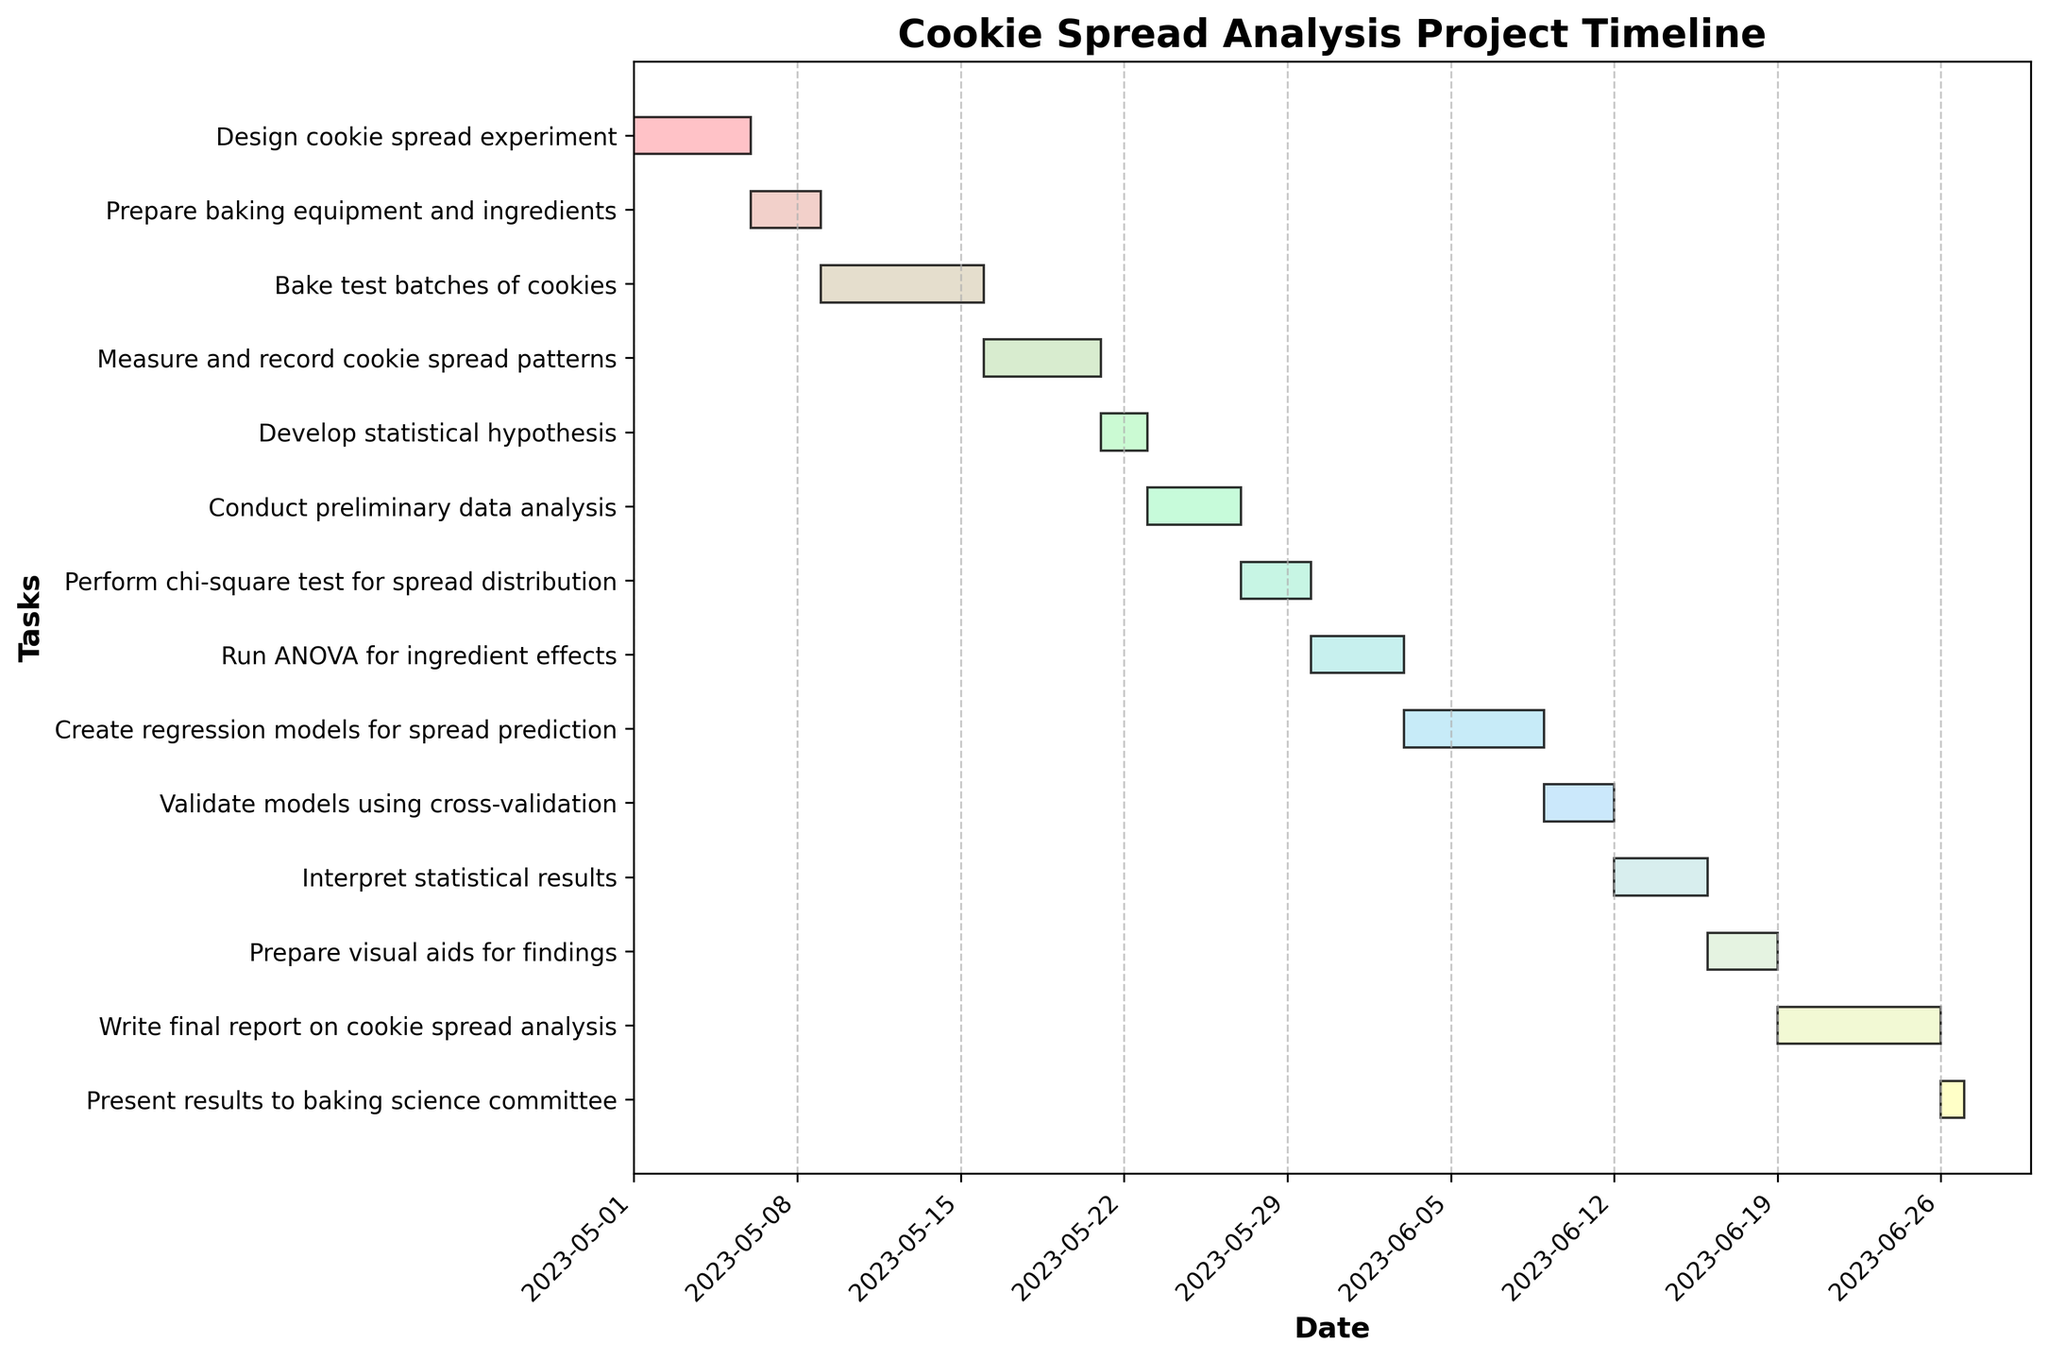How many tasks are listed in the Gantt Chart? By counting the bars in the Gantt Chart, we can determine the number of tasks represented. Since each bar corresponds to a task, we simply count the number of bars.
Answer: 14 What is the title of the Gantt Chart? The title is displayed prominently at the top center of the chart.
Answer: Cookie Spread Analysis Project Timeline Which task has the longest duration and how many days does it span? By examining the length of the bars, we can visually identify which bar is the longest. That bar represents the task with the longest duration.
Answer: Write final report on cookie spread analysis, 7 days Which two tasks start on the same day? To find tasks that start on the same day, we look at the left edge of the bars and identify any that align vertically. Noting the start dates helps in this comparison.
Answer: Validate models using cross-validation and Interpret statistical results How many tasks are scheduled to begin in May? To count the tasks beginning in May, we inspect the start dates on the x-axis and identify which bars start within the range of May 1 to May 31.
Answer: 8 What is the duration of the "Bake test batches of cookies" task? We locate the specific task on the y-axis and track its corresponding bar horizontally to determine the duration. The difference between the start and end dates will give the number of days.
Answer: 7 days Compare the duration of "Conduct preliminary data analysis" and "Run ANOVA for ingredient effects." Which one is longer, and by how many days? By locating both tasks on the Gantt Chart, we measure the graphical length of their bars to find their respective durations, then calculate the difference. "Conduct preliminary data analysis" lasts 4 days, while "Run ANOVA for ingredient effects" lasts 4 days. Hence, neither is longer.
Answer: Both are equal, 4 days Which task starts immediately after "Develop statistical hypothesis" and on what date? By identifying the end date of "Develop statistical hypothesis" and then looking for the next task that starts right after, we find "Conduct preliminary data analysis," which starts on May 23.
Answer: Conduct preliminary data analysis, May 23 How many tasks end on or after June 20? By examining the bars that extend to or beyond June 20, we can count the relevant tasks that meet this criterion.
Answer: 3 What is the last scheduled task and its end date? By scanning the end points of all the bars, we identify the bar that extends the farthest to the right, which represents the last scheduled task.
Answer: Present results to baking science committee, June 26 